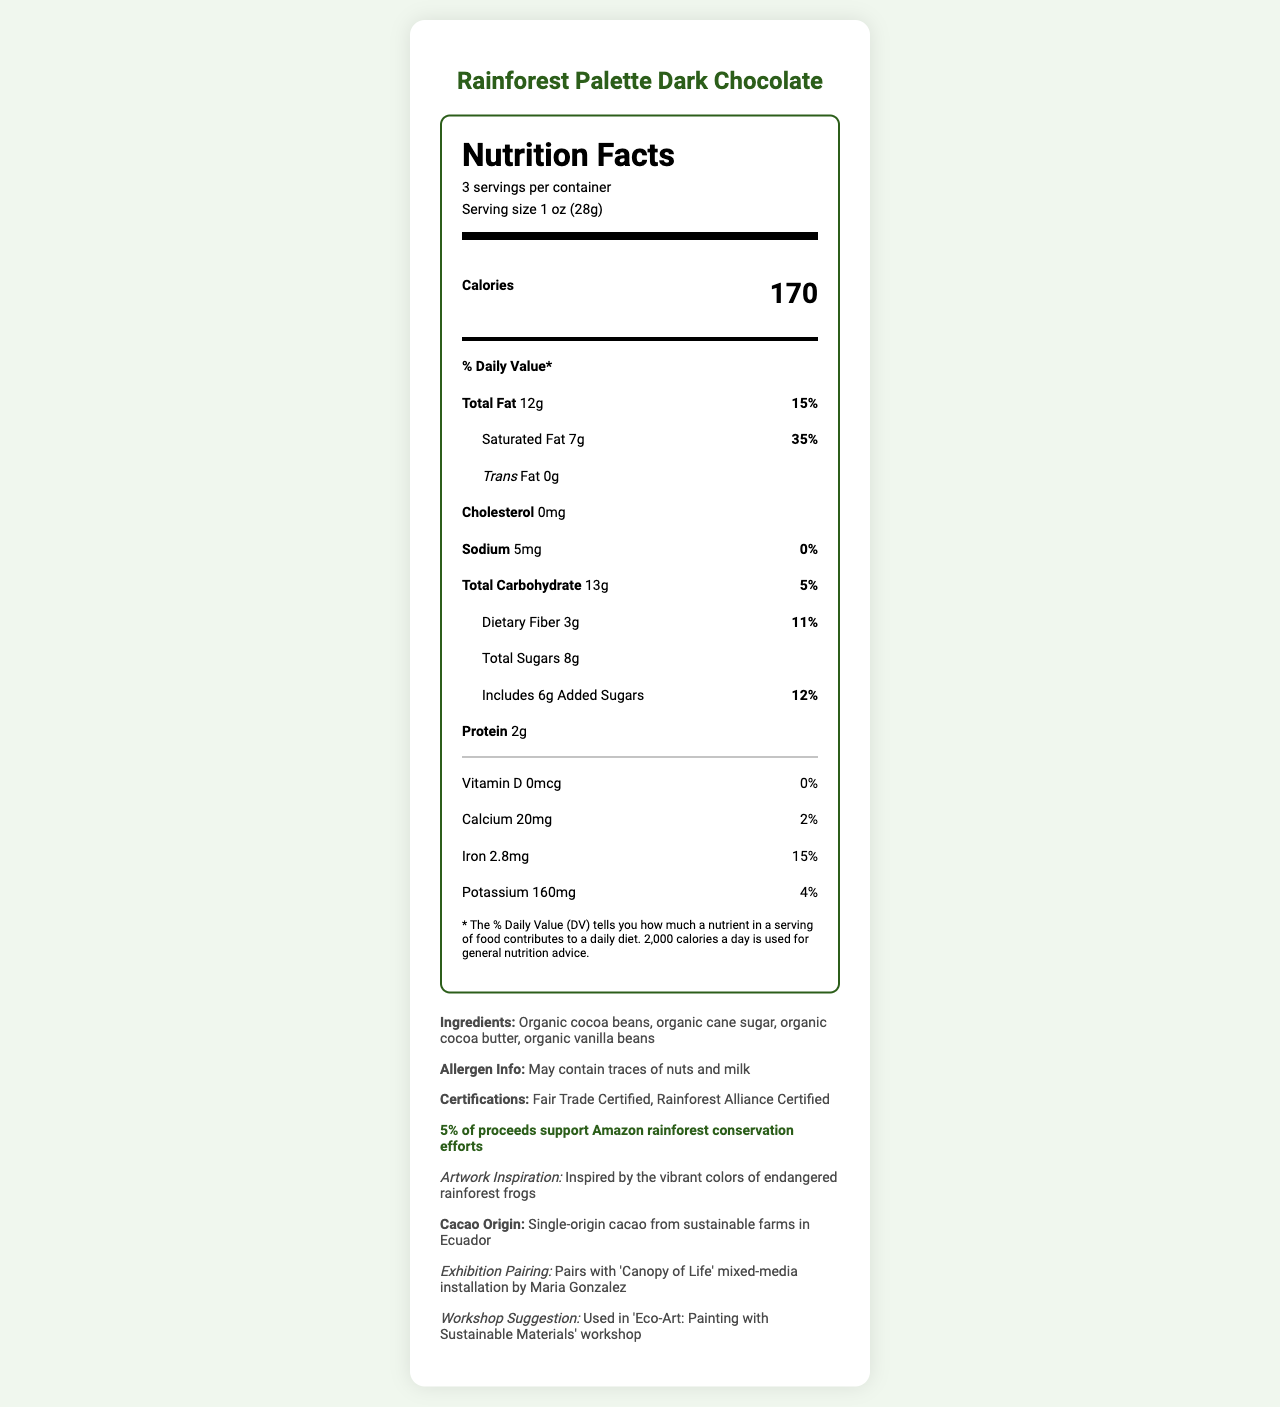what is the product name? The product name is stated at the top of the document.
Answer: Rainforest Palette Dark Chocolate what is the serving size? The serving size is specified in the label header.
Answer: 1 oz (28g) how many calories are in one serving? The calorie count per serving is displayed in the main info section.
Answer: 170 what is the total fat content per serving? The total fat content is listed under the % Daily Value section.
Answer: 12g what are the ingredients? The ingredients list is found in the extra-info section.
Answer: Organic cocoa beans, organic cane sugar, organic cocoa butter, organic vanilla beans how much iron is in each serving, and what percent of the daily value does it represent? The iron content and its daily value percentage are located under the nutrient section.
Answer: 2.8mg, 15% what percentage of daily value of saturated fat does one serving contain? The percentage daily value of saturated fat is specified under the Total Fat section as a sub-nutrient.
Answer: 35% what are the available certifications for the product? The certifications are listed in the extra-info section.
Answer: Fair Trade Certified, Rainforest Alliance Certified how much dietary fiber is in one serving? The dietary fiber content per serving is specified under the Total Carbohydrate section as a sub-nutrient.
Answer: 3g how much of the proceeds support rainforest conservation efforts? The conservation impact statement in the extra-info section mentions that 5% of proceeds support Amazon rainforest conservation efforts.
Answer: 5% which ingredient is not included in the list: Organic cocoa beans, Organic cane sugar, Organic palm oil, Organic vanilla beans? The ingredient list does not include Organic palm oil.
Answer: Organic palm oil Pairs with 'Canopy of Life' mixed-media installation by Maria Gonzalez The exhibition pairing in the extra-info section states that this product pairs with 'Canopy of Life' mixed-media installation by Maria Gonzalez.
Answer: True is the chocolate considered Fair Trade Certified? The extra-info section mentions that the product is Fair Trade Certified.
Answer: Yes does the product contain any cholesterol? The nutrition label states that the cholesterol content is 0mg.
Answer: No who is the artist that designed the 'Canopy of Life' installation? The document refers to Maria Gonzalez as the artist for the 'Canopy of Life' installation and not the document designing artist.
Answer: Not enough information summarize the main purpose and content of the document. The document serves to inform consumers about the nutritional value, ingredients, certifications, and the eco-friendly nature of the Rainforest Palette Dark Chocolate, along with its artistic and conservation-themed connections.
Answer: The document provides detailed nutrition information for Rainforest Palette Dark Chocolate, including serving size, calories, macronutrients, vitamins, and minerals. The product is Fair Trade and Rainforest Alliance Certified, lists its organic ingredients, and supports Amazon rainforest conservation efforts. It also highlights its inspiration and suggested pairings with art installations and workshops. 